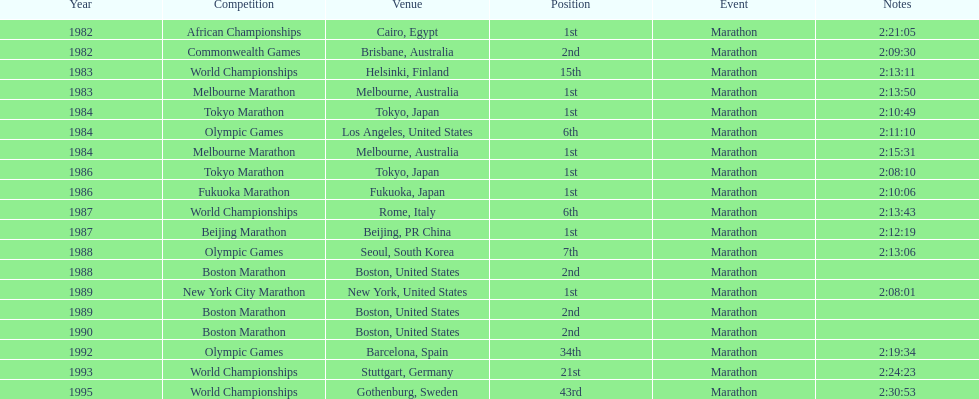What was the first marathon juma ikangaa won? 1982 African Championships. 